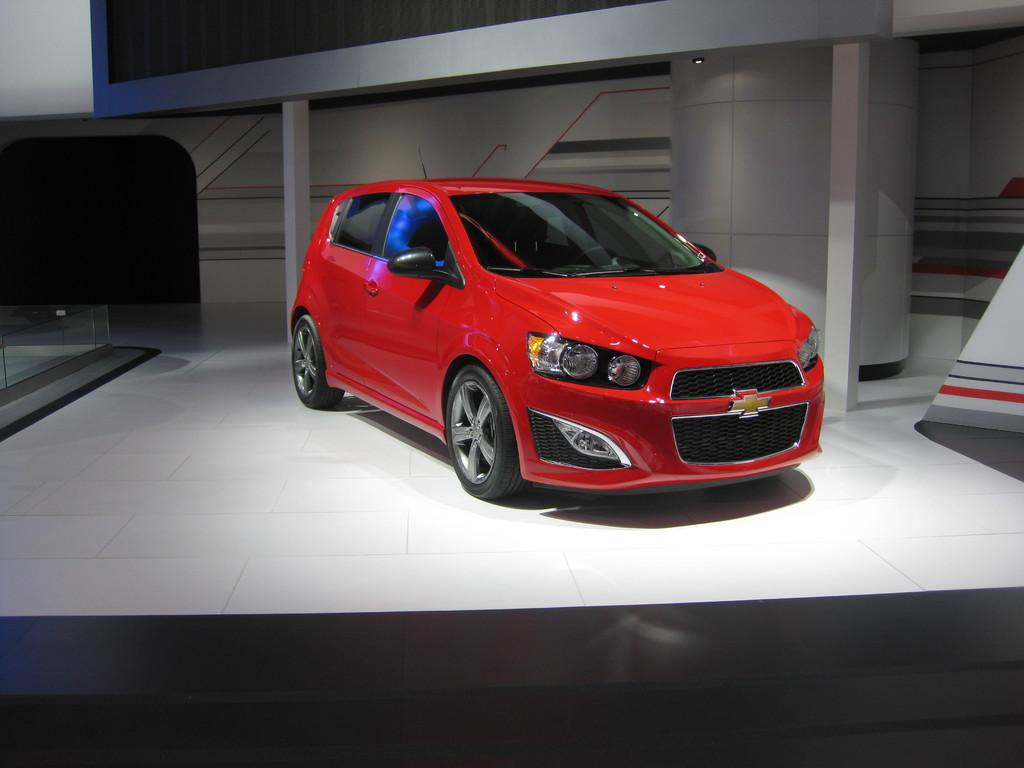What color is the car in the image? The car in the image is red. What is the car resting on in the image? The car is on a surface in the image. What can be seen in the background of the image? There are walls visible in the background of the image. Can you see a squirrel sitting on a plate on the sofa in the image? No, there is no squirrel, plate, or sofa present in the image. 